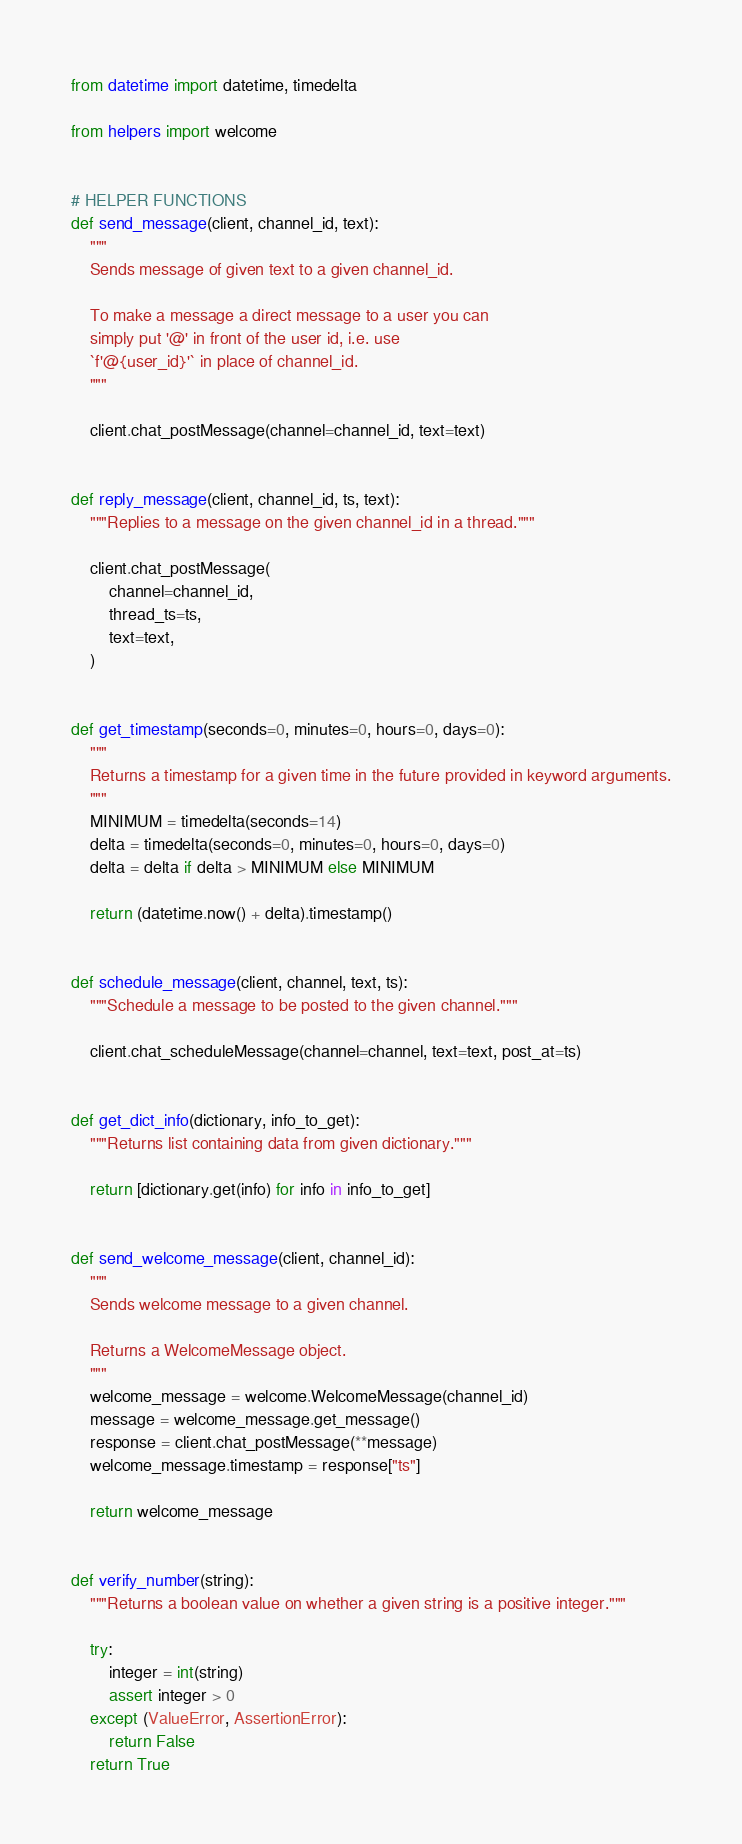<code> <loc_0><loc_0><loc_500><loc_500><_Python_>from datetime import datetime, timedelta

from helpers import welcome


# HELPER FUNCTIONS
def send_message(client, channel_id, text):
    """
    Sends message of given text to a given channel_id.

    To make a message a direct message to a user you can
    simply put '@' in front of the user id, i.e. use
    `f'@{user_id}'` in place of channel_id.
    """

    client.chat_postMessage(channel=channel_id, text=text)


def reply_message(client, channel_id, ts, text):
    """Replies to a message on the given channel_id in a thread."""

    client.chat_postMessage(
        channel=channel_id,
        thread_ts=ts,
        text=text,
    )


def get_timestamp(seconds=0, minutes=0, hours=0, days=0):
    """
    Returns a timestamp for a given time in the future provided in keyword arguments.
    """
    MINIMUM = timedelta(seconds=14)
    delta = timedelta(seconds=0, minutes=0, hours=0, days=0)
    delta = delta if delta > MINIMUM else MINIMUM

    return (datetime.now() + delta).timestamp()


def schedule_message(client, channel, text, ts):
    """Schedule a message to be posted to the given channel."""

    client.chat_scheduleMessage(channel=channel, text=text, post_at=ts)


def get_dict_info(dictionary, info_to_get):
    """Returns list containing data from given dictionary."""

    return [dictionary.get(info) for info in info_to_get]


def send_welcome_message(client, channel_id):
    """
    Sends welcome message to a given channel.

    Returns a WelcomeMessage object.
    """
    welcome_message = welcome.WelcomeMessage(channel_id)
    message = welcome_message.get_message()
    response = client.chat_postMessage(**message)
    welcome_message.timestamp = response["ts"]

    return welcome_message


def verify_number(string):
    """Returns a boolean value on whether a given string is a positive integer."""

    try:
        integer = int(string)
        assert integer > 0
    except (ValueError, AssertionError):
        return False
    return True
</code> 